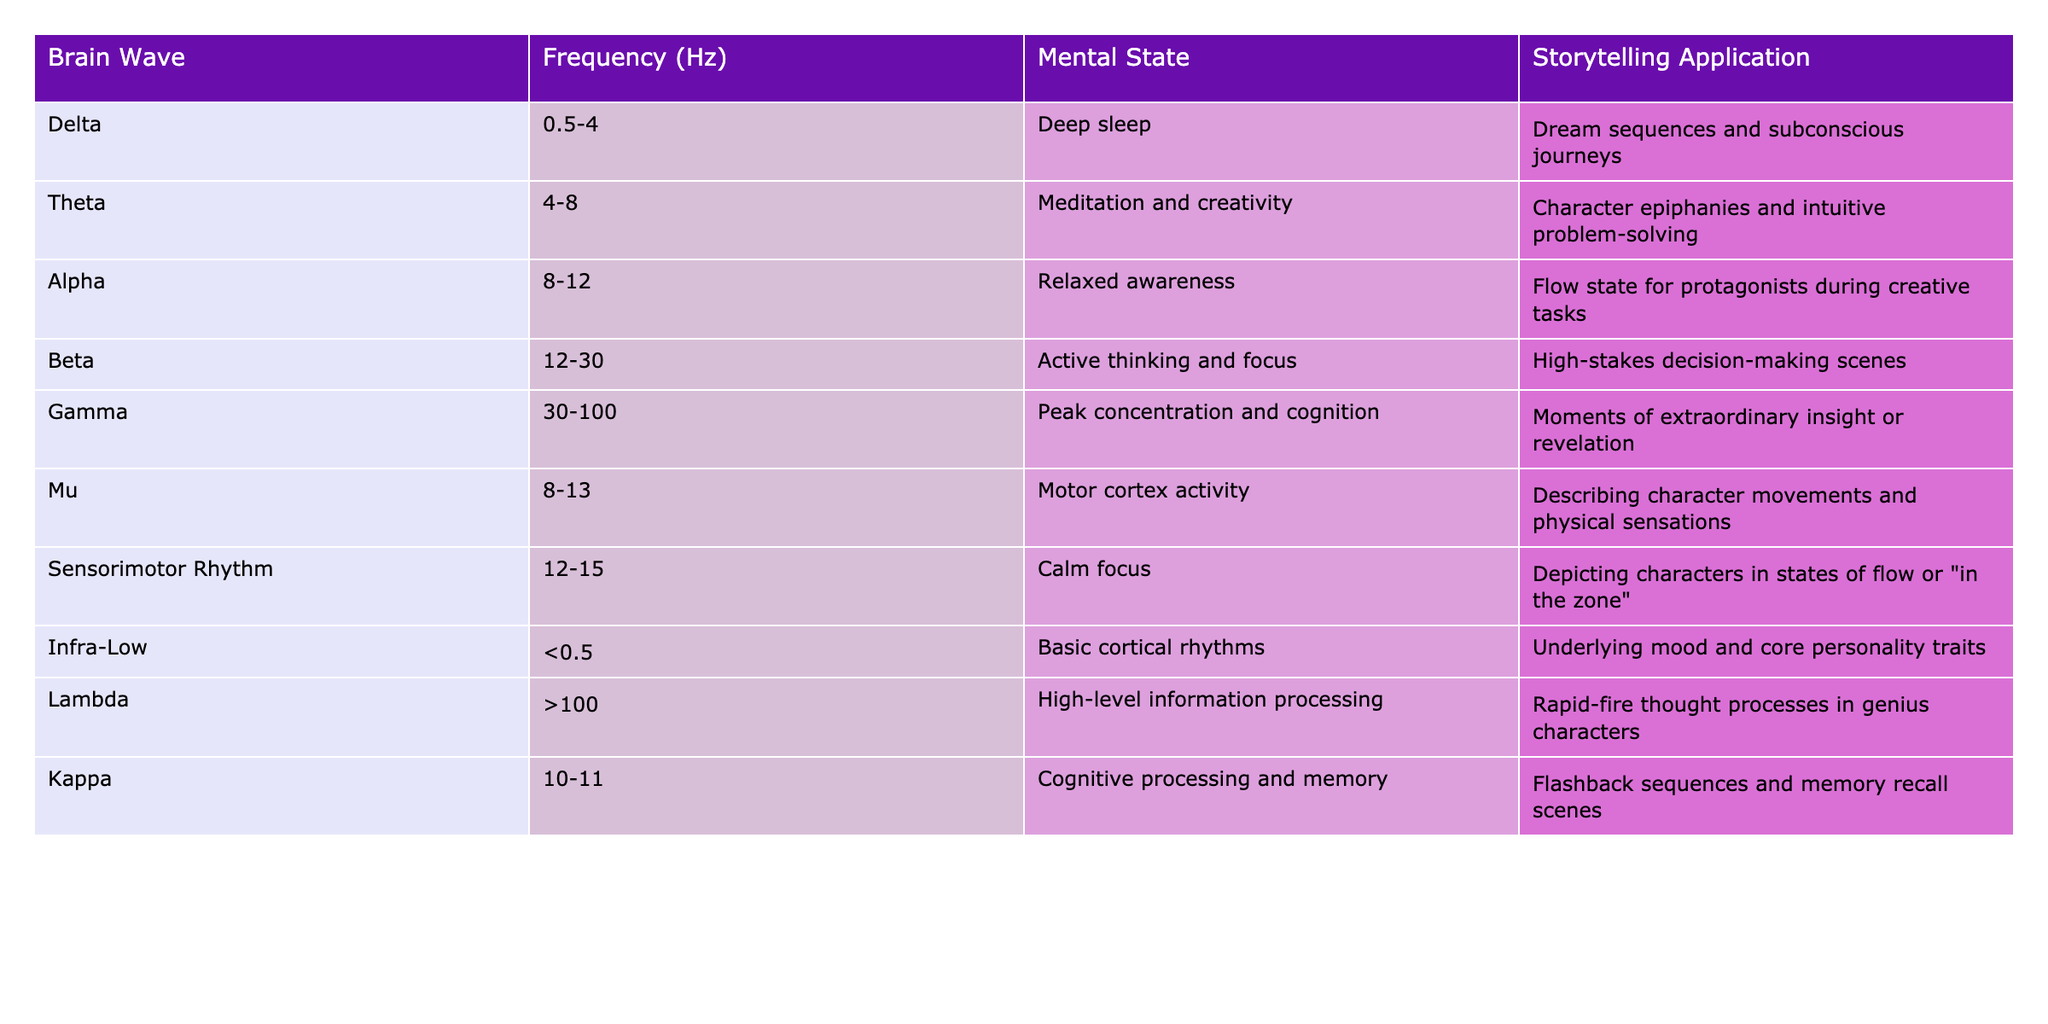What is the frequency range for Delta brain waves? The table lists the frequency range for Delta brain waves as 0.5-4 Hz, directly stated in the table.
Answer: 0.5-4 Hz Which mental state is associated with Gamma brain waves? According to the table, Gamma brain waves are associated with peak concentration and cognition, as indicated in the mental state column.
Answer: Peak concentration and cognition What are the two brain waves associated with relaxed awareness? The table shows that both Alpha and Mu brain waves are associated with relaxed awareness, as Mu is listed with a frequency range of 8-13 Hz and Alpha is 8-12 Hz.
Answer: Alpha and Mu Is the frequency range for Theta brain waves lower than that of Beta brain waves? Theta brain waves have a frequency range of 4-8 Hz, while Beta brain waves have a frequency range of 12-30 Hz, so Theta is indeed lower than Beta.
Answer: Yes What storytelling application is associated with Beta brain waves? The table specifically links high-stakes decision-making scenes as the storytelling application for Beta brain waves.
Answer: High-stakes decision-making scenes What is the frequency range of Infra-Low brain waves? Infra-Low brain waves have a frequency range of less than 0.5 Hz, as indicated in the table.
Answer: Less than 0.5 Hz If a character experiences a moment of extraordinary insight, which brain wave frequency might they be in? The table states that Gamma brain waves (30-100 Hz) are linked to moments of extraordinary insight or revelation, therefore, a character might be in this frequency range during such moments.
Answer: Gamma brain waves (30-100 Hz) Which brain wave is linked to character epiphanies according to the table? Theta brain waves (4-8 Hz) are specifically associated with meditation and creativity, which includes character epiphanies as stated in the storytelling application section of the table.
Answer: Theta brain waves What is the average frequency range of Kappa and Mu brain waves combined? Kappa ranges from 10-11 Hz and Mu ranges from 8-13 Hz. To find the average, we can combine the ranges: Kappa has an average of 10.5 Hz and Mu has an average of 10.5 Hz. So the combined average would be (10.5 + 10.5)/2 = 10.5 Hz.
Answer: 10.5 Hz Which brain wave frequency has the broadest range? By examining the table, the Gamma brain waves have the highest frequency range between 30-100 Hz, making it the broadest range when compared to others listed.
Answer: Gamma brain waves (30-100 Hz) What mental state is associated with the Lambda brain waves? The table indicates that the Lambda brain waves are associated with high-level information processing, as mentioned in the mental state section.
Answer: High-level information processing 